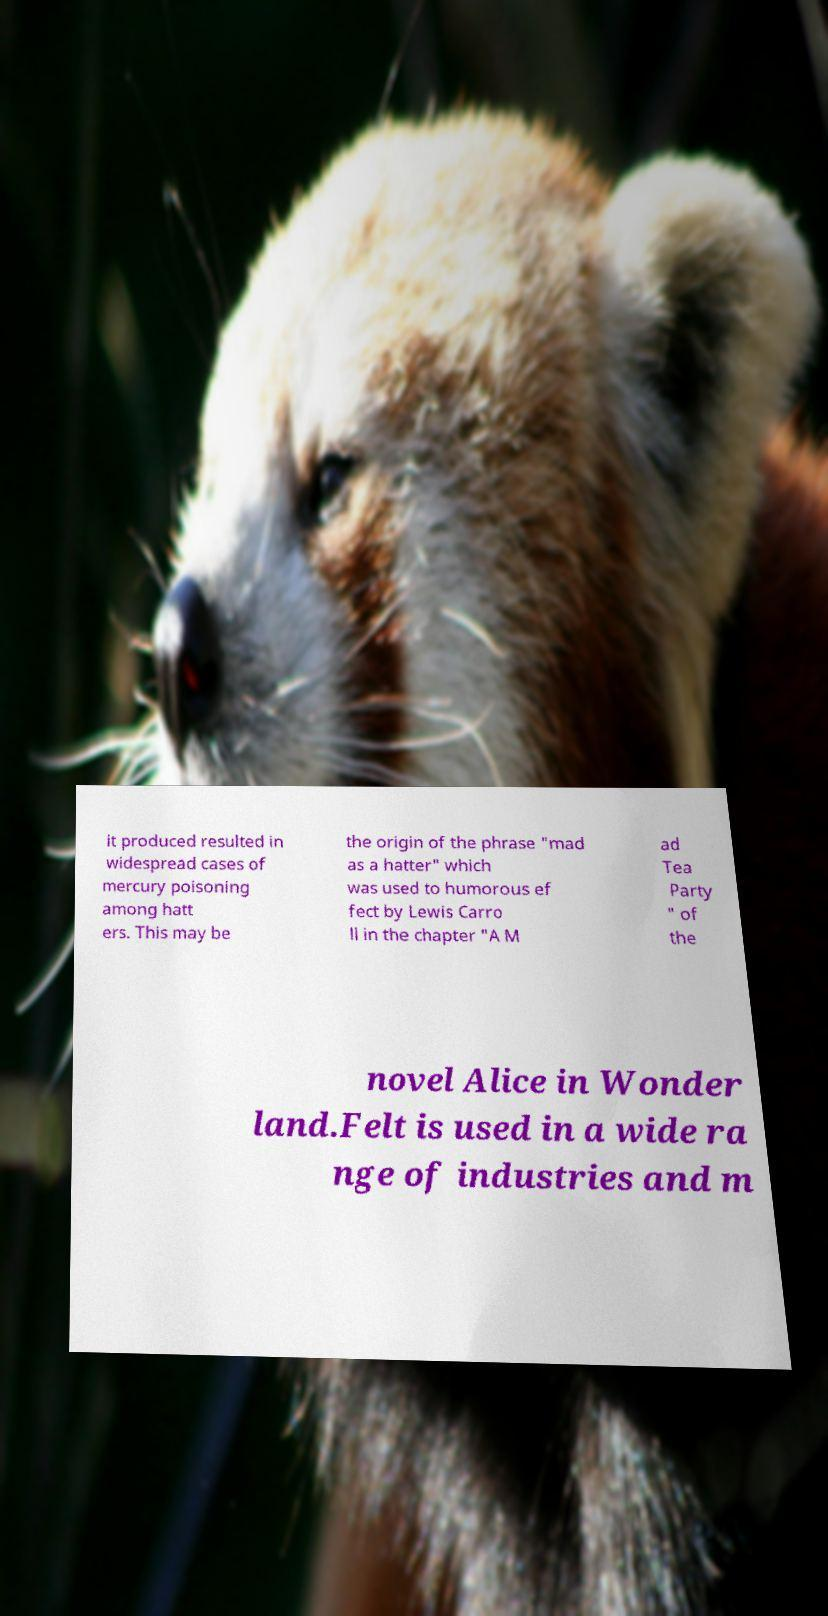There's text embedded in this image that I need extracted. Can you transcribe it verbatim? it produced resulted in widespread cases of mercury poisoning among hatt ers. This may be the origin of the phrase "mad as a hatter" which was used to humorous ef fect by Lewis Carro ll in the chapter "A M ad Tea Party " of the novel Alice in Wonder land.Felt is used in a wide ra nge of industries and m 